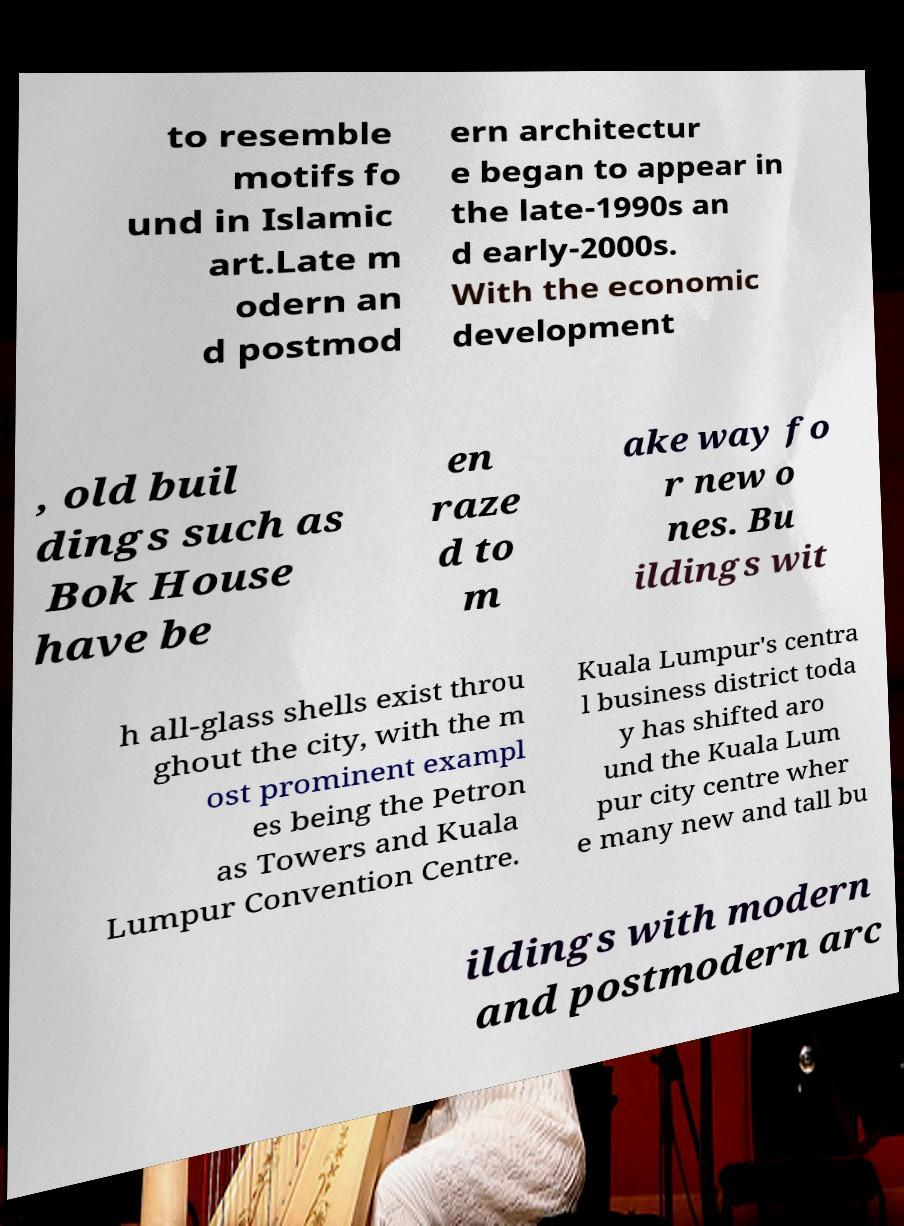There's text embedded in this image that I need extracted. Can you transcribe it verbatim? to resemble motifs fo und in Islamic art.Late m odern an d postmod ern architectur e began to appear in the late-1990s an d early-2000s. With the economic development , old buil dings such as Bok House have be en raze d to m ake way fo r new o nes. Bu ildings wit h all-glass shells exist throu ghout the city, with the m ost prominent exampl es being the Petron as Towers and Kuala Lumpur Convention Centre. Kuala Lumpur's centra l business district toda y has shifted aro und the Kuala Lum pur city centre wher e many new and tall bu ildings with modern and postmodern arc 